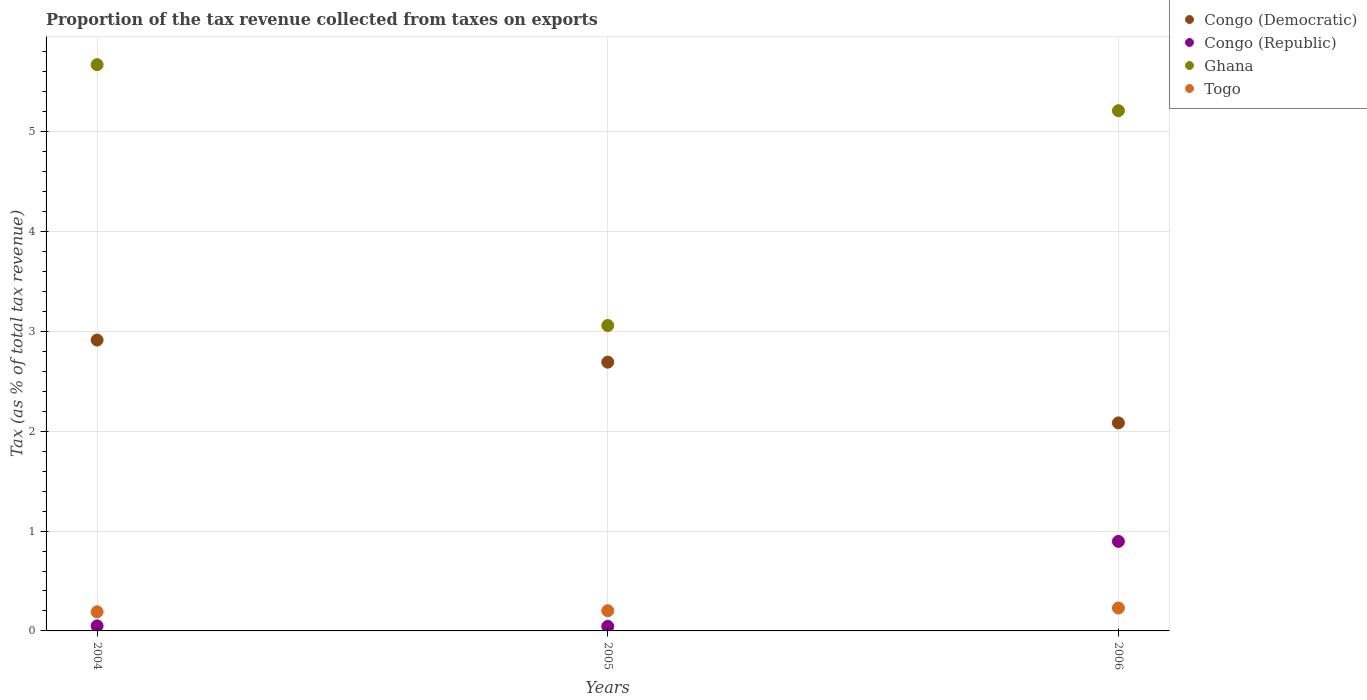How many different coloured dotlines are there?
Your answer should be compact. 4. Is the number of dotlines equal to the number of legend labels?
Offer a terse response. Yes. What is the proportion of the tax revenue collected in Congo (Democratic) in 2005?
Your answer should be compact. 2.69. Across all years, what is the maximum proportion of the tax revenue collected in Togo?
Your answer should be very brief. 0.23. Across all years, what is the minimum proportion of the tax revenue collected in Togo?
Your answer should be compact. 0.19. In which year was the proportion of the tax revenue collected in Congo (Democratic) minimum?
Ensure brevity in your answer.  2006. What is the total proportion of the tax revenue collected in Congo (Democratic) in the graph?
Your response must be concise. 7.69. What is the difference between the proportion of the tax revenue collected in Congo (Democratic) in 2005 and that in 2006?
Give a very brief answer. 0.61. What is the difference between the proportion of the tax revenue collected in Congo (Republic) in 2004 and the proportion of the tax revenue collected in Togo in 2005?
Keep it short and to the point. -0.15. What is the average proportion of the tax revenue collected in Congo (Republic) per year?
Make the answer very short. 0.33. In the year 2005, what is the difference between the proportion of the tax revenue collected in Congo (Democratic) and proportion of the tax revenue collected in Congo (Republic)?
Provide a short and direct response. 2.65. What is the ratio of the proportion of the tax revenue collected in Ghana in 2004 to that in 2006?
Make the answer very short. 1.09. Is the proportion of the tax revenue collected in Congo (Democratic) in 2004 less than that in 2005?
Provide a succinct answer. No. What is the difference between the highest and the second highest proportion of the tax revenue collected in Congo (Democratic)?
Offer a terse response. 0.22. What is the difference between the highest and the lowest proportion of the tax revenue collected in Togo?
Offer a very short reply. 0.04. In how many years, is the proportion of the tax revenue collected in Congo (Democratic) greater than the average proportion of the tax revenue collected in Congo (Democratic) taken over all years?
Your answer should be very brief. 2. Is it the case that in every year, the sum of the proportion of the tax revenue collected in Togo and proportion of the tax revenue collected in Ghana  is greater than the proportion of the tax revenue collected in Congo (Democratic)?
Your answer should be compact. Yes. Is the proportion of the tax revenue collected in Togo strictly less than the proportion of the tax revenue collected in Congo (Republic) over the years?
Your answer should be very brief. No. What is the difference between two consecutive major ticks on the Y-axis?
Provide a succinct answer. 1. Are the values on the major ticks of Y-axis written in scientific E-notation?
Your answer should be very brief. No. Does the graph contain any zero values?
Ensure brevity in your answer.  No. Does the graph contain grids?
Provide a short and direct response. Yes. How are the legend labels stacked?
Give a very brief answer. Vertical. What is the title of the graph?
Your response must be concise. Proportion of the tax revenue collected from taxes on exports. What is the label or title of the X-axis?
Give a very brief answer. Years. What is the label or title of the Y-axis?
Your response must be concise. Tax (as % of total tax revenue). What is the Tax (as % of total tax revenue) in Congo (Democratic) in 2004?
Keep it short and to the point. 2.91. What is the Tax (as % of total tax revenue) in Congo (Republic) in 2004?
Your response must be concise. 0.05. What is the Tax (as % of total tax revenue) of Ghana in 2004?
Offer a very short reply. 5.67. What is the Tax (as % of total tax revenue) of Togo in 2004?
Your answer should be compact. 0.19. What is the Tax (as % of total tax revenue) in Congo (Democratic) in 2005?
Offer a terse response. 2.69. What is the Tax (as % of total tax revenue) of Congo (Republic) in 2005?
Ensure brevity in your answer.  0.05. What is the Tax (as % of total tax revenue) in Ghana in 2005?
Offer a terse response. 3.06. What is the Tax (as % of total tax revenue) in Togo in 2005?
Your response must be concise. 0.2. What is the Tax (as % of total tax revenue) in Congo (Democratic) in 2006?
Give a very brief answer. 2.08. What is the Tax (as % of total tax revenue) of Congo (Republic) in 2006?
Provide a short and direct response. 0.9. What is the Tax (as % of total tax revenue) of Ghana in 2006?
Ensure brevity in your answer.  5.21. What is the Tax (as % of total tax revenue) in Togo in 2006?
Your response must be concise. 0.23. Across all years, what is the maximum Tax (as % of total tax revenue) in Congo (Democratic)?
Provide a succinct answer. 2.91. Across all years, what is the maximum Tax (as % of total tax revenue) in Congo (Republic)?
Make the answer very short. 0.9. Across all years, what is the maximum Tax (as % of total tax revenue) in Ghana?
Your response must be concise. 5.67. Across all years, what is the maximum Tax (as % of total tax revenue) of Togo?
Your response must be concise. 0.23. Across all years, what is the minimum Tax (as % of total tax revenue) in Congo (Democratic)?
Your answer should be very brief. 2.08. Across all years, what is the minimum Tax (as % of total tax revenue) of Congo (Republic)?
Make the answer very short. 0.05. Across all years, what is the minimum Tax (as % of total tax revenue) of Ghana?
Provide a succinct answer. 3.06. Across all years, what is the minimum Tax (as % of total tax revenue) in Togo?
Make the answer very short. 0.19. What is the total Tax (as % of total tax revenue) of Congo (Democratic) in the graph?
Give a very brief answer. 7.69. What is the total Tax (as % of total tax revenue) of Ghana in the graph?
Offer a terse response. 13.94. What is the total Tax (as % of total tax revenue) in Togo in the graph?
Provide a short and direct response. 0.62. What is the difference between the Tax (as % of total tax revenue) in Congo (Democratic) in 2004 and that in 2005?
Keep it short and to the point. 0.22. What is the difference between the Tax (as % of total tax revenue) in Congo (Republic) in 2004 and that in 2005?
Give a very brief answer. 0.01. What is the difference between the Tax (as % of total tax revenue) of Ghana in 2004 and that in 2005?
Ensure brevity in your answer.  2.61. What is the difference between the Tax (as % of total tax revenue) of Togo in 2004 and that in 2005?
Give a very brief answer. -0.01. What is the difference between the Tax (as % of total tax revenue) of Congo (Democratic) in 2004 and that in 2006?
Your answer should be very brief. 0.83. What is the difference between the Tax (as % of total tax revenue) in Congo (Republic) in 2004 and that in 2006?
Keep it short and to the point. -0.85. What is the difference between the Tax (as % of total tax revenue) of Ghana in 2004 and that in 2006?
Give a very brief answer. 0.46. What is the difference between the Tax (as % of total tax revenue) of Togo in 2004 and that in 2006?
Ensure brevity in your answer.  -0.04. What is the difference between the Tax (as % of total tax revenue) in Congo (Democratic) in 2005 and that in 2006?
Make the answer very short. 0.61. What is the difference between the Tax (as % of total tax revenue) in Congo (Republic) in 2005 and that in 2006?
Keep it short and to the point. -0.85. What is the difference between the Tax (as % of total tax revenue) of Ghana in 2005 and that in 2006?
Keep it short and to the point. -2.15. What is the difference between the Tax (as % of total tax revenue) in Togo in 2005 and that in 2006?
Give a very brief answer. -0.03. What is the difference between the Tax (as % of total tax revenue) of Congo (Democratic) in 2004 and the Tax (as % of total tax revenue) of Congo (Republic) in 2005?
Offer a terse response. 2.87. What is the difference between the Tax (as % of total tax revenue) in Congo (Democratic) in 2004 and the Tax (as % of total tax revenue) in Ghana in 2005?
Offer a very short reply. -0.15. What is the difference between the Tax (as % of total tax revenue) of Congo (Democratic) in 2004 and the Tax (as % of total tax revenue) of Togo in 2005?
Your answer should be compact. 2.71. What is the difference between the Tax (as % of total tax revenue) of Congo (Republic) in 2004 and the Tax (as % of total tax revenue) of Ghana in 2005?
Offer a terse response. -3.01. What is the difference between the Tax (as % of total tax revenue) in Congo (Republic) in 2004 and the Tax (as % of total tax revenue) in Togo in 2005?
Your answer should be compact. -0.15. What is the difference between the Tax (as % of total tax revenue) of Ghana in 2004 and the Tax (as % of total tax revenue) of Togo in 2005?
Keep it short and to the point. 5.47. What is the difference between the Tax (as % of total tax revenue) in Congo (Democratic) in 2004 and the Tax (as % of total tax revenue) in Congo (Republic) in 2006?
Offer a very short reply. 2.02. What is the difference between the Tax (as % of total tax revenue) of Congo (Democratic) in 2004 and the Tax (as % of total tax revenue) of Ghana in 2006?
Make the answer very short. -2.3. What is the difference between the Tax (as % of total tax revenue) of Congo (Democratic) in 2004 and the Tax (as % of total tax revenue) of Togo in 2006?
Offer a very short reply. 2.68. What is the difference between the Tax (as % of total tax revenue) of Congo (Republic) in 2004 and the Tax (as % of total tax revenue) of Ghana in 2006?
Provide a succinct answer. -5.16. What is the difference between the Tax (as % of total tax revenue) of Congo (Republic) in 2004 and the Tax (as % of total tax revenue) of Togo in 2006?
Offer a terse response. -0.18. What is the difference between the Tax (as % of total tax revenue) in Ghana in 2004 and the Tax (as % of total tax revenue) in Togo in 2006?
Give a very brief answer. 5.44. What is the difference between the Tax (as % of total tax revenue) in Congo (Democratic) in 2005 and the Tax (as % of total tax revenue) in Congo (Republic) in 2006?
Your answer should be very brief. 1.8. What is the difference between the Tax (as % of total tax revenue) in Congo (Democratic) in 2005 and the Tax (as % of total tax revenue) in Ghana in 2006?
Your answer should be very brief. -2.52. What is the difference between the Tax (as % of total tax revenue) in Congo (Democratic) in 2005 and the Tax (as % of total tax revenue) in Togo in 2006?
Offer a terse response. 2.46. What is the difference between the Tax (as % of total tax revenue) in Congo (Republic) in 2005 and the Tax (as % of total tax revenue) in Ghana in 2006?
Your answer should be very brief. -5.17. What is the difference between the Tax (as % of total tax revenue) of Congo (Republic) in 2005 and the Tax (as % of total tax revenue) of Togo in 2006?
Your response must be concise. -0.18. What is the difference between the Tax (as % of total tax revenue) of Ghana in 2005 and the Tax (as % of total tax revenue) of Togo in 2006?
Offer a very short reply. 2.83. What is the average Tax (as % of total tax revenue) of Congo (Democratic) per year?
Offer a terse response. 2.56. What is the average Tax (as % of total tax revenue) in Congo (Republic) per year?
Ensure brevity in your answer.  0.33. What is the average Tax (as % of total tax revenue) of Ghana per year?
Give a very brief answer. 4.65. What is the average Tax (as % of total tax revenue) in Togo per year?
Offer a very short reply. 0.21. In the year 2004, what is the difference between the Tax (as % of total tax revenue) in Congo (Democratic) and Tax (as % of total tax revenue) in Congo (Republic)?
Offer a very short reply. 2.86. In the year 2004, what is the difference between the Tax (as % of total tax revenue) in Congo (Democratic) and Tax (as % of total tax revenue) in Ghana?
Offer a very short reply. -2.76. In the year 2004, what is the difference between the Tax (as % of total tax revenue) in Congo (Democratic) and Tax (as % of total tax revenue) in Togo?
Keep it short and to the point. 2.72. In the year 2004, what is the difference between the Tax (as % of total tax revenue) of Congo (Republic) and Tax (as % of total tax revenue) of Ghana?
Your answer should be compact. -5.62. In the year 2004, what is the difference between the Tax (as % of total tax revenue) in Congo (Republic) and Tax (as % of total tax revenue) in Togo?
Make the answer very short. -0.14. In the year 2004, what is the difference between the Tax (as % of total tax revenue) of Ghana and Tax (as % of total tax revenue) of Togo?
Give a very brief answer. 5.48. In the year 2005, what is the difference between the Tax (as % of total tax revenue) in Congo (Democratic) and Tax (as % of total tax revenue) in Congo (Republic)?
Make the answer very short. 2.65. In the year 2005, what is the difference between the Tax (as % of total tax revenue) of Congo (Democratic) and Tax (as % of total tax revenue) of Ghana?
Provide a short and direct response. -0.37. In the year 2005, what is the difference between the Tax (as % of total tax revenue) in Congo (Democratic) and Tax (as % of total tax revenue) in Togo?
Your answer should be very brief. 2.49. In the year 2005, what is the difference between the Tax (as % of total tax revenue) in Congo (Republic) and Tax (as % of total tax revenue) in Ghana?
Your answer should be very brief. -3.01. In the year 2005, what is the difference between the Tax (as % of total tax revenue) in Congo (Republic) and Tax (as % of total tax revenue) in Togo?
Keep it short and to the point. -0.16. In the year 2005, what is the difference between the Tax (as % of total tax revenue) of Ghana and Tax (as % of total tax revenue) of Togo?
Give a very brief answer. 2.86. In the year 2006, what is the difference between the Tax (as % of total tax revenue) in Congo (Democratic) and Tax (as % of total tax revenue) in Congo (Republic)?
Ensure brevity in your answer.  1.19. In the year 2006, what is the difference between the Tax (as % of total tax revenue) in Congo (Democratic) and Tax (as % of total tax revenue) in Ghana?
Your response must be concise. -3.13. In the year 2006, what is the difference between the Tax (as % of total tax revenue) of Congo (Democratic) and Tax (as % of total tax revenue) of Togo?
Make the answer very short. 1.85. In the year 2006, what is the difference between the Tax (as % of total tax revenue) of Congo (Republic) and Tax (as % of total tax revenue) of Ghana?
Provide a succinct answer. -4.31. In the year 2006, what is the difference between the Tax (as % of total tax revenue) of Congo (Republic) and Tax (as % of total tax revenue) of Togo?
Offer a very short reply. 0.67. In the year 2006, what is the difference between the Tax (as % of total tax revenue) in Ghana and Tax (as % of total tax revenue) in Togo?
Make the answer very short. 4.98. What is the ratio of the Tax (as % of total tax revenue) in Congo (Democratic) in 2004 to that in 2005?
Offer a very short reply. 1.08. What is the ratio of the Tax (as % of total tax revenue) of Congo (Republic) in 2004 to that in 2005?
Provide a short and direct response. 1.11. What is the ratio of the Tax (as % of total tax revenue) in Ghana in 2004 to that in 2005?
Give a very brief answer. 1.85. What is the ratio of the Tax (as % of total tax revenue) in Togo in 2004 to that in 2005?
Give a very brief answer. 0.95. What is the ratio of the Tax (as % of total tax revenue) in Congo (Democratic) in 2004 to that in 2006?
Make the answer very short. 1.4. What is the ratio of the Tax (as % of total tax revenue) in Congo (Republic) in 2004 to that in 2006?
Provide a short and direct response. 0.06. What is the ratio of the Tax (as % of total tax revenue) in Ghana in 2004 to that in 2006?
Your response must be concise. 1.09. What is the ratio of the Tax (as % of total tax revenue) in Togo in 2004 to that in 2006?
Offer a very short reply. 0.83. What is the ratio of the Tax (as % of total tax revenue) in Congo (Democratic) in 2005 to that in 2006?
Your answer should be compact. 1.29. What is the ratio of the Tax (as % of total tax revenue) of Congo (Republic) in 2005 to that in 2006?
Offer a terse response. 0.05. What is the ratio of the Tax (as % of total tax revenue) of Ghana in 2005 to that in 2006?
Your answer should be very brief. 0.59. What is the ratio of the Tax (as % of total tax revenue) in Togo in 2005 to that in 2006?
Make the answer very short. 0.88. What is the difference between the highest and the second highest Tax (as % of total tax revenue) in Congo (Democratic)?
Make the answer very short. 0.22. What is the difference between the highest and the second highest Tax (as % of total tax revenue) of Congo (Republic)?
Your response must be concise. 0.85. What is the difference between the highest and the second highest Tax (as % of total tax revenue) of Ghana?
Offer a terse response. 0.46. What is the difference between the highest and the second highest Tax (as % of total tax revenue) in Togo?
Provide a succinct answer. 0.03. What is the difference between the highest and the lowest Tax (as % of total tax revenue) in Congo (Democratic)?
Your response must be concise. 0.83. What is the difference between the highest and the lowest Tax (as % of total tax revenue) of Congo (Republic)?
Ensure brevity in your answer.  0.85. What is the difference between the highest and the lowest Tax (as % of total tax revenue) in Ghana?
Provide a short and direct response. 2.61. What is the difference between the highest and the lowest Tax (as % of total tax revenue) of Togo?
Provide a succinct answer. 0.04. 